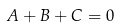<formula> <loc_0><loc_0><loc_500><loc_500>A + B + C = 0</formula> 